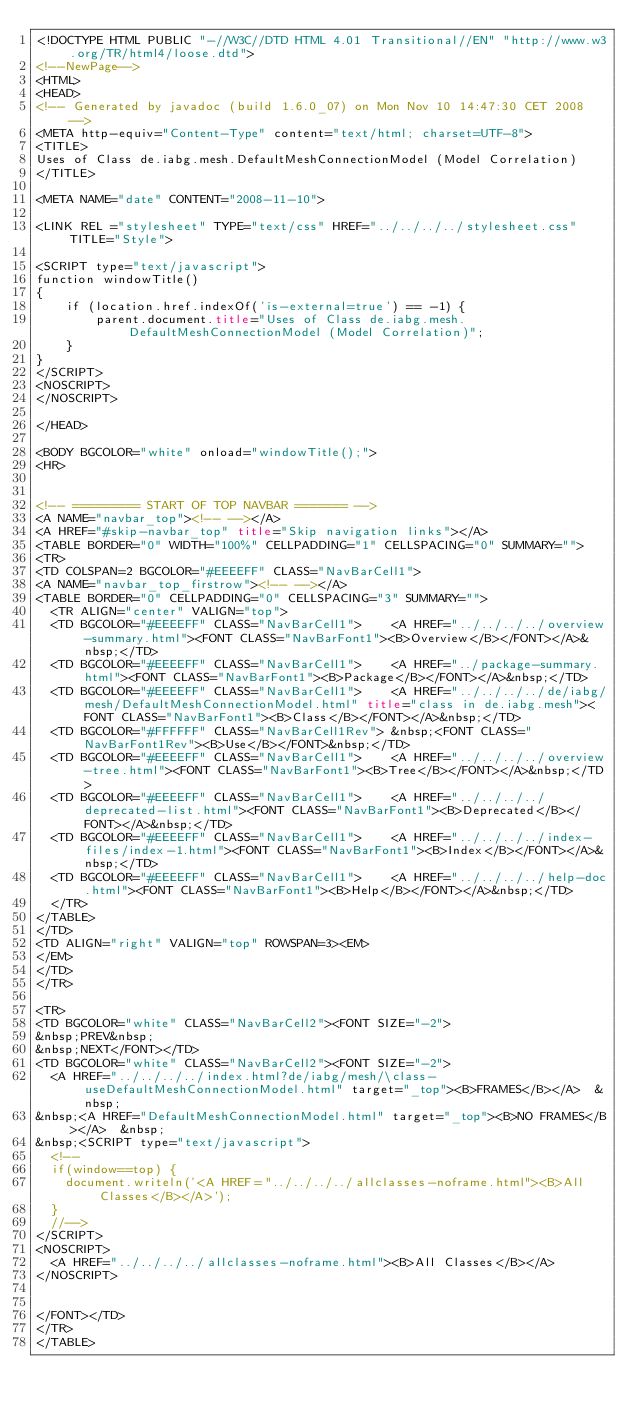<code> <loc_0><loc_0><loc_500><loc_500><_HTML_><!DOCTYPE HTML PUBLIC "-//W3C//DTD HTML 4.01 Transitional//EN" "http://www.w3.org/TR/html4/loose.dtd">
<!--NewPage-->
<HTML>
<HEAD>
<!-- Generated by javadoc (build 1.6.0_07) on Mon Nov 10 14:47:30 CET 2008 -->
<META http-equiv="Content-Type" content="text/html; charset=UTF-8">
<TITLE>
Uses of Class de.iabg.mesh.DefaultMeshConnectionModel (Model Correlation)
</TITLE>

<META NAME="date" CONTENT="2008-11-10">

<LINK REL ="stylesheet" TYPE="text/css" HREF="../../../../stylesheet.css" TITLE="Style">

<SCRIPT type="text/javascript">
function windowTitle()
{
    if (location.href.indexOf('is-external=true') == -1) {
        parent.document.title="Uses of Class de.iabg.mesh.DefaultMeshConnectionModel (Model Correlation)";
    }
}
</SCRIPT>
<NOSCRIPT>
</NOSCRIPT>

</HEAD>

<BODY BGCOLOR="white" onload="windowTitle();">
<HR>


<!-- ========= START OF TOP NAVBAR ======= -->
<A NAME="navbar_top"><!-- --></A>
<A HREF="#skip-navbar_top" title="Skip navigation links"></A>
<TABLE BORDER="0" WIDTH="100%" CELLPADDING="1" CELLSPACING="0" SUMMARY="">
<TR>
<TD COLSPAN=2 BGCOLOR="#EEEEFF" CLASS="NavBarCell1">
<A NAME="navbar_top_firstrow"><!-- --></A>
<TABLE BORDER="0" CELLPADDING="0" CELLSPACING="3" SUMMARY="">
  <TR ALIGN="center" VALIGN="top">
  <TD BGCOLOR="#EEEEFF" CLASS="NavBarCell1">    <A HREF="../../../../overview-summary.html"><FONT CLASS="NavBarFont1"><B>Overview</B></FONT></A>&nbsp;</TD>
  <TD BGCOLOR="#EEEEFF" CLASS="NavBarCell1">    <A HREF="../package-summary.html"><FONT CLASS="NavBarFont1"><B>Package</B></FONT></A>&nbsp;</TD>
  <TD BGCOLOR="#EEEEFF" CLASS="NavBarCell1">    <A HREF="../../../../de/iabg/mesh/DefaultMeshConnectionModel.html" title="class in de.iabg.mesh"><FONT CLASS="NavBarFont1"><B>Class</B></FONT></A>&nbsp;</TD>
  <TD BGCOLOR="#FFFFFF" CLASS="NavBarCell1Rev"> &nbsp;<FONT CLASS="NavBarFont1Rev"><B>Use</B></FONT>&nbsp;</TD>
  <TD BGCOLOR="#EEEEFF" CLASS="NavBarCell1">    <A HREF="../../../../overview-tree.html"><FONT CLASS="NavBarFont1"><B>Tree</B></FONT></A>&nbsp;</TD>
  <TD BGCOLOR="#EEEEFF" CLASS="NavBarCell1">    <A HREF="../../../../deprecated-list.html"><FONT CLASS="NavBarFont1"><B>Deprecated</B></FONT></A>&nbsp;</TD>
  <TD BGCOLOR="#EEEEFF" CLASS="NavBarCell1">    <A HREF="../../../../index-files/index-1.html"><FONT CLASS="NavBarFont1"><B>Index</B></FONT></A>&nbsp;</TD>
  <TD BGCOLOR="#EEEEFF" CLASS="NavBarCell1">    <A HREF="../../../../help-doc.html"><FONT CLASS="NavBarFont1"><B>Help</B></FONT></A>&nbsp;</TD>
  </TR>
</TABLE>
</TD>
<TD ALIGN="right" VALIGN="top" ROWSPAN=3><EM>
</EM>
</TD>
</TR>

<TR>
<TD BGCOLOR="white" CLASS="NavBarCell2"><FONT SIZE="-2">
&nbsp;PREV&nbsp;
&nbsp;NEXT</FONT></TD>
<TD BGCOLOR="white" CLASS="NavBarCell2"><FONT SIZE="-2">
  <A HREF="../../../../index.html?de/iabg/mesh/\class-useDefaultMeshConnectionModel.html" target="_top"><B>FRAMES</B></A>  &nbsp;
&nbsp;<A HREF="DefaultMeshConnectionModel.html" target="_top"><B>NO FRAMES</B></A>  &nbsp;
&nbsp;<SCRIPT type="text/javascript">
  <!--
  if(window==top) {
    document.writeln('<A HREF="../../../../allclasses-noframe.html"><B>All Classes</B></A>');
  }
  //-->
</SCRIPT>
<NOSCRIPT>
  <A HREF="../../../../allclasses-noframe.html"><B>All Classes</B></A>
</NOSCRIPT>


</FONT></TD>
</TR>
</TABLE></code> 